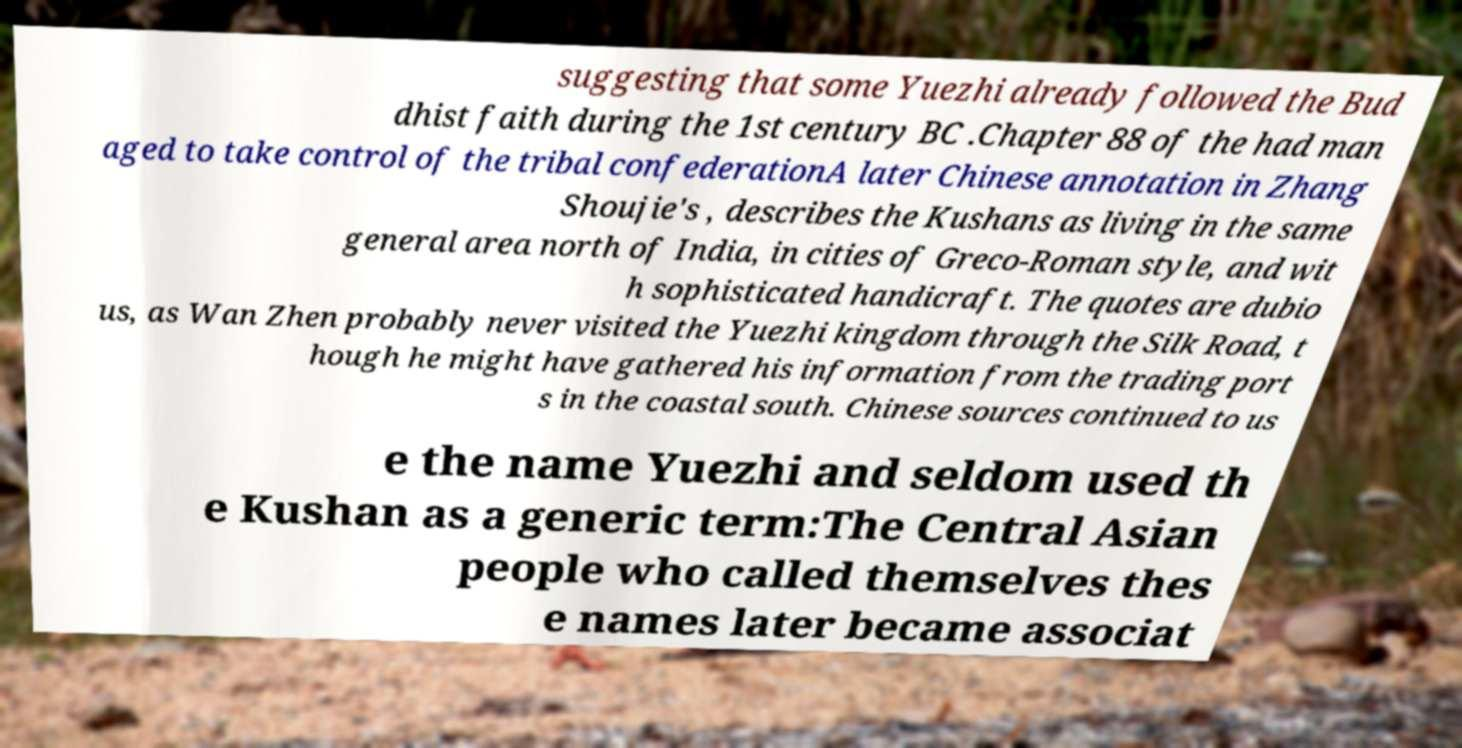Please read and relay the text visible in this image. What does it say? suggesting that some Yuezhi already followed the Bud dhist faith during the 1st century BC .Chapter 88 of the had man aged to take control of the tribal confederationA later Chinese annotation in Zhang Shoujie's , describes the Kushans as living in the same general area north of India, in cities of Greco-Roman style, and wit h sophisticated handicraft. The quotes are dubio us, as Wan Zhen probably never visited the Yuezhi kingdom through the Silk Road, t hough he might have gathered his information from the trading port s in the coastal south. Chinese sources continued to us e the name Yuezhi and seldom used th e Kushan as a generic term:The Central Asian people who called themselves thes e names later became associat 